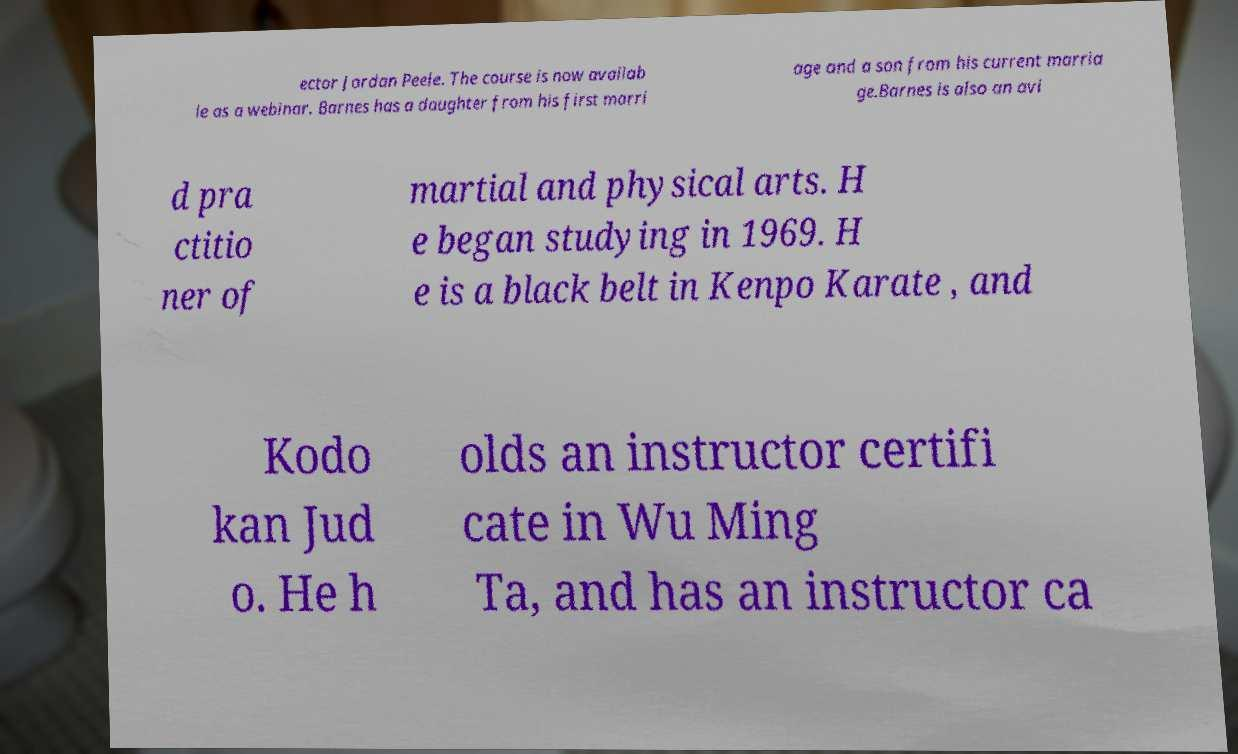Please read and relay the text visible in this image. What does it say? ector Jordan Peele. The course is now availab le as a webinar. Barnes has a daughter from his first marri age and a son from his current marria ge.Barnes is also an avi d pra ctitio ner of martial and physical arts. H e began studying in 1969. H e is a black belt in Kenpo Karate , and Kodo kan Jud o. He h olds an instructor certifi cate in Wu Ming Ta, and has an instructor ca 